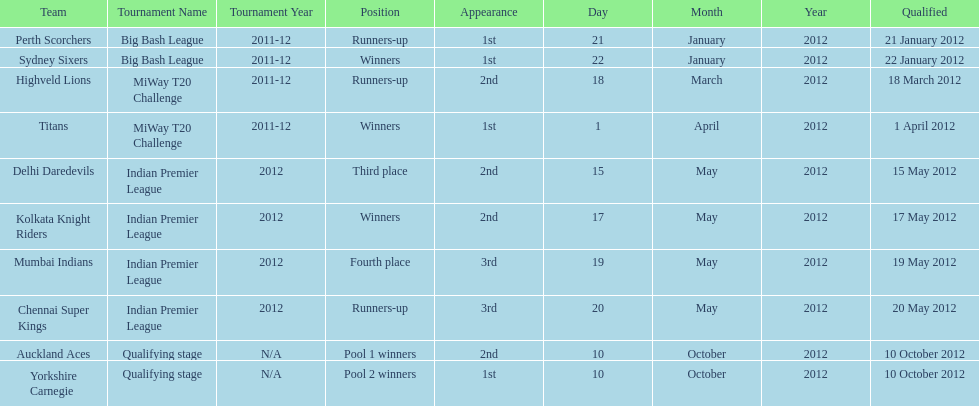What is the total number of teams that qualified? 10. Give me the full table as a dictionary. {'header': ['Team', 'Tournament Name', 'Tournament Year', 'Position', 'Appearance', 'Day', 'Month', 'Year', 'Qualified'], 'rows': [['Perth Scorchers', 'Big Bash League', '2011-12', 'Runners-up', '1st', '21', 'January', '2012', '21 January 2012'], ['Sydney Sixers', 'Big Bash League', '2011-12', 'Winners', '1st', '22', 'January', '2012', '22 January 2012'], ['Highveld Lions', 'MiWay T20 Challenge', '2011-12', 'Runners-up', '2nd', '18', 'March', '2012', '18 March 2012'], ['Titans', 'MiWay T20 Challenge', '2011-12', 'Winners', '1st', '1', 'April', '2012', '1 April 2012'], ['Delhi Daredevils', 'Indian Premier League', '2012', 'Third place', '2nd', '15', 'May', '2012', '15 May 2012'], ['Kolkata Knight Riders', 'Indian Premier League', '2012', 'Winners', '2nd', '17', 'May', '2012', '17 May 2012'], ['Mumbai Indians', 'Indian Premier League', '2012', 'Fourth place', '3rd', '19', 'May', '2012', '19 May 2012'], ['Chennai Super Kings', 'Indian Premier League', '2012', 'Runners-up', '3rd', '20', 'May', '2012', '20 May 2012'], ['Auckland Aces', 'Qualifying stage', 'N/A', 'Pool 1 winners', '2nd', '10', 'October', '2012', '10 October 2012'], ['Yorkshire Carnegie', 'Qualifying stage', 'N/A', 'Pool 2 winners', '1st', '10', 'October', '2012', '10 October 2012']]} 